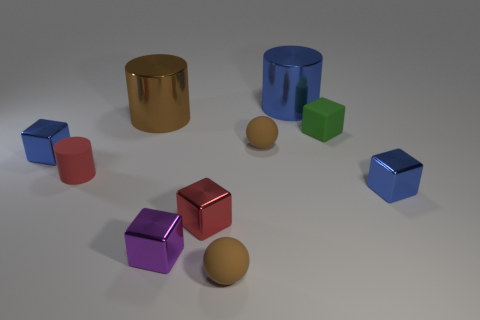There is a blue thing that is both behind the tiny red cylinder and in front of the big blue cylinder; how big is it?
Keep it short and to the point. Small. There is a large blue thing that is the same shape as the large brown object; what is its material?
Provide a succinct answer. Metal. What is the tiny brown sphere that is in front of the small blue thing that is on the left side of the big brown cylinder made of?
Your response must be concise. Rubber. Is the shape of the small purple object the same as the blue shiny object that is behind the small matte block?
Offer a very short reply. No. What number of metal things are either tiny green objects or blue cubes?
Give a very brief answer. 2. What color is the large shiny object that is right of the brown matte sphere that is in front of the blue block to the left of the red cylinder?
Keep it short and to the point. Blue. What number of other objects are the same material as the tiny red cube?
Ensure brevity in your answer.  5. There is a big brown metal object left of the green matte block; does it have the same shape as the tiny green rubber object?
Keep it short and to the point. No. How many large objects are either red rubber balls or purple cubes?
Provide a short and direct response. 0. Are there the same number of red cylinders that are right of the purple cube and blue objects that are right of the small matte cube?
Your answer should be very brief. No. 